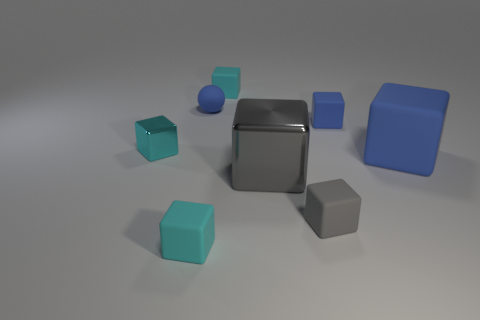Subtract all cyan blocks. How many were subtracted if there are1cyan blocks left? 2 Subtract all purple cylinders. How many cyan cubes are left? 3 Subtract 1 cubes. How many cubes are left? 6 Subtract all tiny gray blocks. How many blocks are left? 6 Add 1 matte balls. How many objects exist? 9 Subtract all gray blocks. How many blocks are left? 5 Subtract all purple cubes. Subtract all cyan cylinders. How many cubes are left? 7 Subtract all cubes. How many objects are left? 1 Add 1 purple matte balls. How many purple matte balls exist? 1 Subtract 0 brown spheres. How many objects are left? 8 